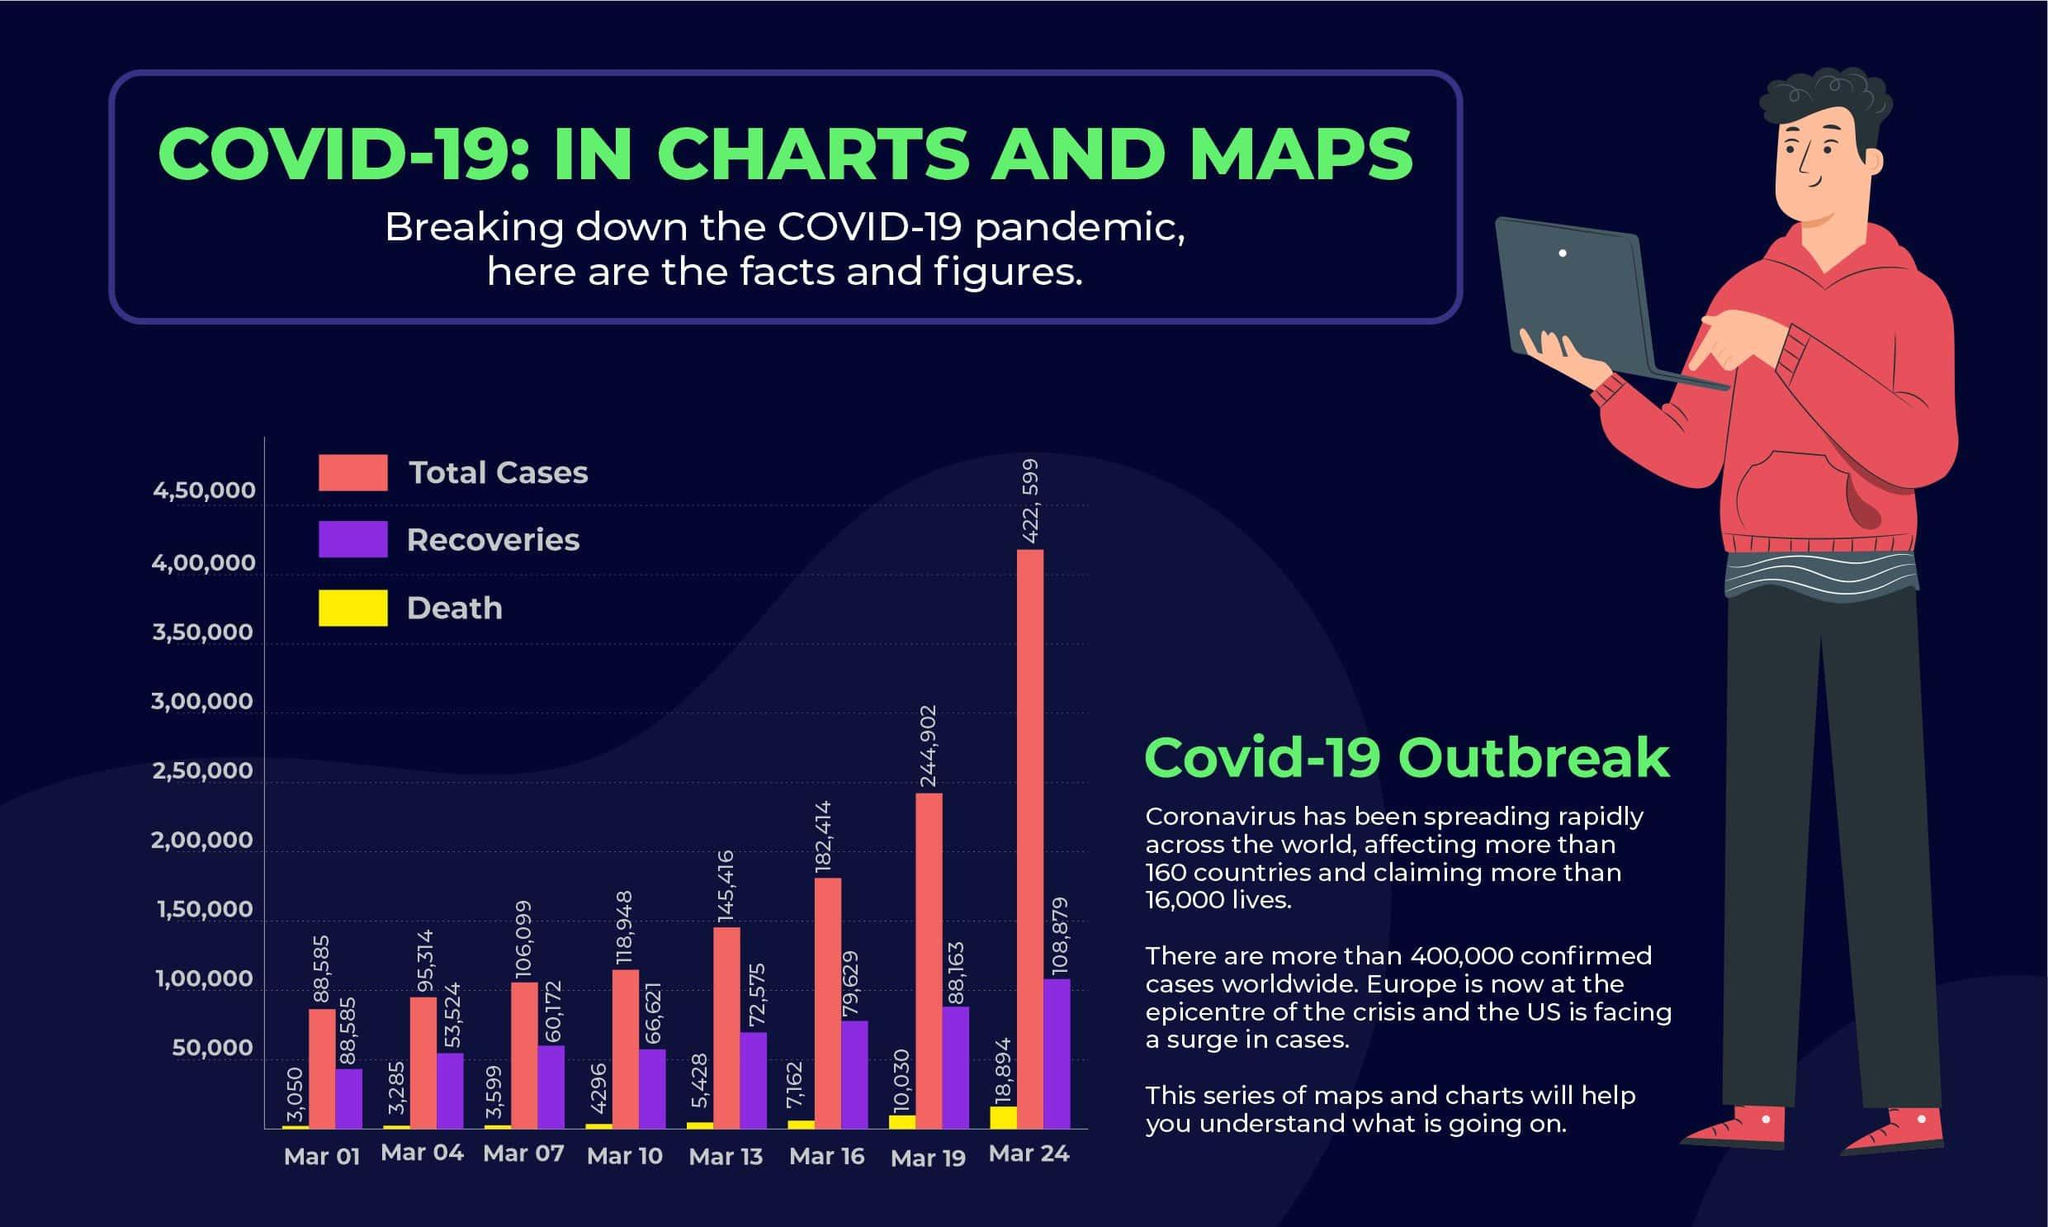Draw attention to some important aspects in this diagram. On March 24, the total cases reached the highest point. Yellow has been the color that has been used to represent death in the graph. The total number of cases increased by 125,954 from March 10 to March 19. On March 1st and March 4th, the total number of cases was below 1,00,000. On March 16, there were a total of 182,414 cases. 